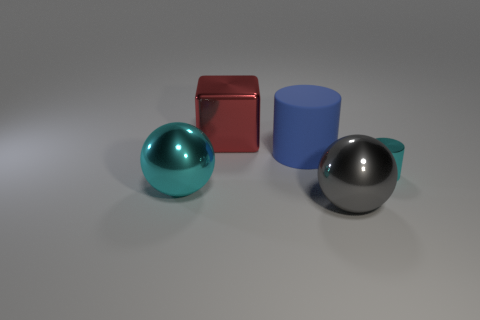Add 3 purple cylinders. How many objects exist? 8 Subtract all red cylinders. Subtract all blue spheres. How many cylinders are left? 2 Subtract all blocks. How many objects are left? 4 Subtract 0 brown blocks. How many objects are left? 5 Subtract all big blue objects. Subtract all tiny purple metallic balls. How many objects are left? 4 Add 1 blue rubber objects. How many blue rubber objects are left? 2 Add 2 shiny cylinders. How many shiny cylinders exist? 3 